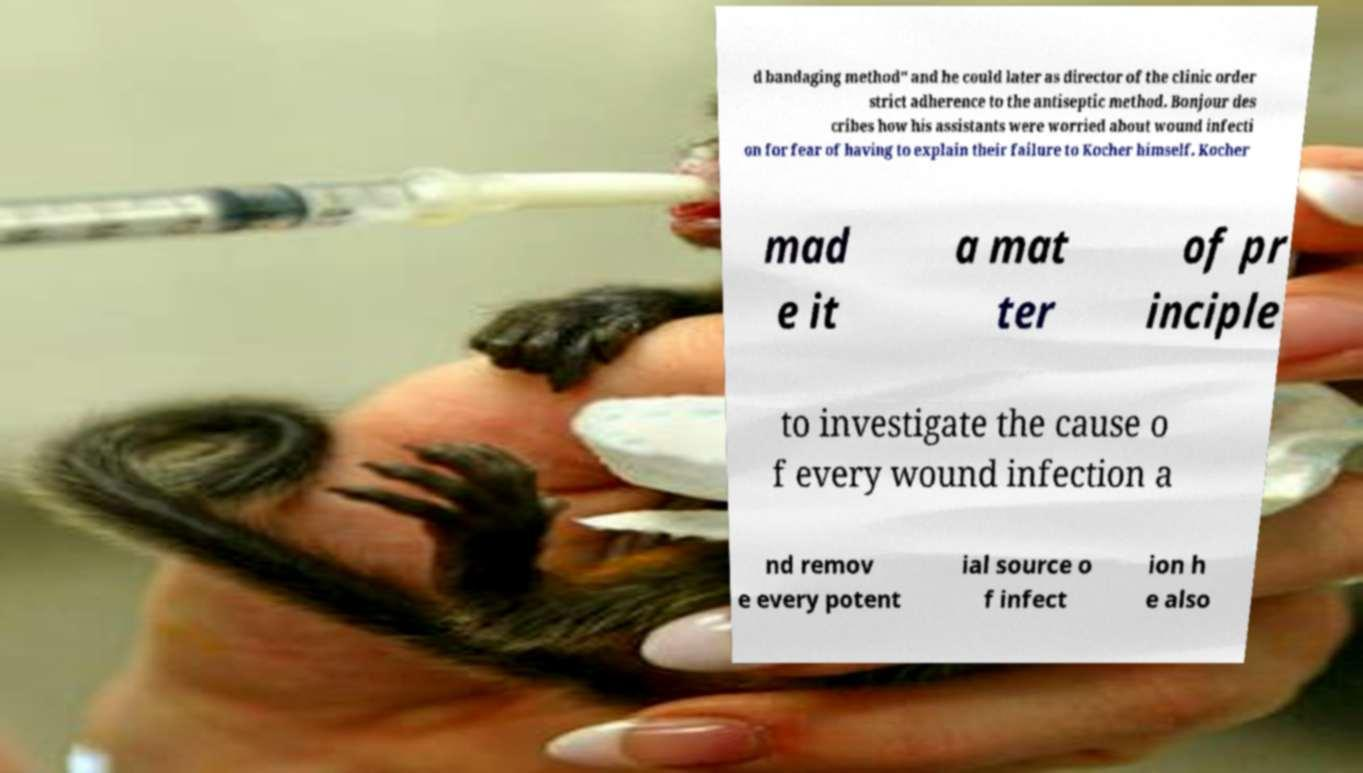Could you assist in decoding the text presented in this image and type it out clearly? d bandaging method" and he could later as director of the clinic order strict adherence to the antiseptic method. Bonjour des cribes how his assistants were worried about wound infecti on for fear of having to explain their failure to Kocher himself. Kocher mad e it a mat ter of pr inciple to investigate the cause o f every wound infection a nd remov e every potent ial source o f infect ion h e also 